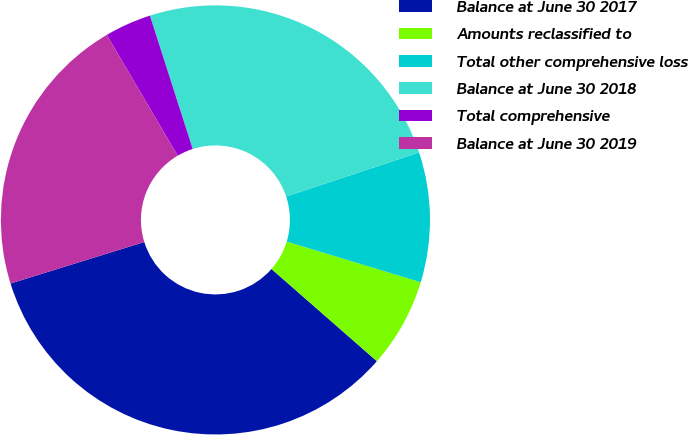Convert chart to OTSL. <chart><loc_0><loc_0><loc_500><loc_500><pie_chart><fcel>Balance at June 30 2017<fcel>Amounts reclassified to<fcel>Total other comprehensive loss<fcel>Balance at June 30 2018<fcel>Total comprehensive<fcel>Balance at June 30 2019<nl><fcel>33.77%<fcel>6.75%<fcel>9.78%<fcel>24.85%<fcel>3.51%<fcel>21.34%<nl></chart> 